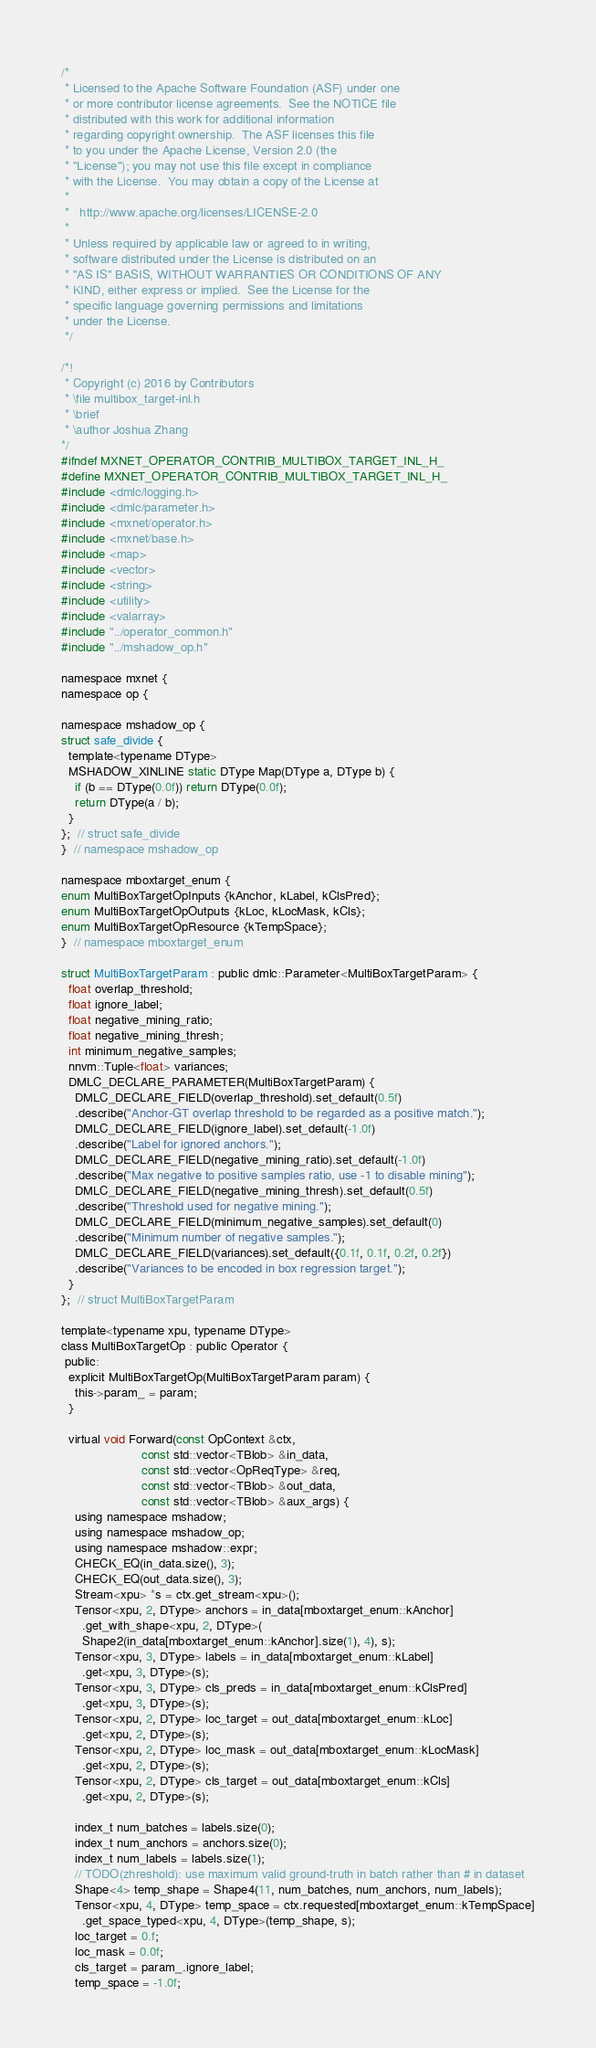<code> <loc_0><loc_0><loc_500><loc_500><_C_>/*
 * Licensed to the Apache Software Foundation (ASF) under one
 * or more contributor license agreements.  See the NOTICE file
 * distributed with this work for additional information
 * regarding copyright ownership.  The ASF licenses this file
 * to you under the Apache License, Version 2.0 (the
 * "License"); you may not use this file except in compliance
 * with the License.  You may obtain a copy of the License at
 *
 *   http://www.apache.org/licenses/LICENSE-2.0
 *
 * Unless required by applicable law or agreed to in writing,
 * software distributed under the License is distributed on an
 * "AS IS" BASIS, WITHOUT WARRANTIES OR CONDITIONS OF ANY
 * KIND, either express or implied.  See the License for the
 * specific language governing permissions and limitations
 * under the License.
 */

/*!
 * Copyright (c) 2016 by Contributors
 * \file multibox_target-inl.h
 * \brief
 * \author Joshua Zhang
*/
#ifndef MXNET_OPERATOR_CONTRIB_MULTIBOX_TARGET_INL_H_
#define MXNET_OPERATOR_CONTRIB_MULTIBOX_TARGET_INL_H_
#include <dmlc/logging.h>
#include <dmlc/parameter.h>
#include <mxnet/operator.h>
#include <mxnet/base.h>
#include <map>
#include <vector>
#include <string>
#include <utility>
#include <valarray>
#include "../operator_common.h"
#include "../mshadow_op.h"

namespace mxnet {
namespace op {

namespace mshadow_op {
struct safe_divide {
  template<typename DType>
  MSHADOW_XINLINE static DType Map(DType a, DType b) {
    if (b == DType(0.0f)) return DType(0.0f);
    return DType(a / b);
  }
};  // struct safe_divide
}  // namespace mshadow_op

namespace mboxtarget_enum {
enum MultiBoxTargetOpInputs {kAnchor, kLabel, kClsPred};
enum MultiBoxTargetOpOutputs {kLoc, kLocMask, kCls};
enum MultiBoxTargetOpResource {kTempSpace};
}  // namespace mboxtarget_enum

struct MultiBoxTargetParam : public dmlc::Parameter<MultiBoxTargetParam> {
  float overlap_threshold;
  float ignore_label;
  float negative_mining_ratio;
  float negative_mining_thresh;
  int minimum_negative_samples;
  nnvm::Tuple<float> variances;
  DMLC_DECLARE_PARAMETER(MultiBoxTargetParam) {
    DMLC_DECLARE_FIELD(overlap_threshold).set_default(0.5f)
    .describe("Anchor-GT overlap threshold to be regarded as a positive match.");
    DMLC_DECLARE_FIELD(ignore_label).set_default(-1.0f)
    .describe("Label for ignored anchors.");
    DMLC_DECLARE_FIELD(negative_mining_ratio).set_default(-1.0f)
    .describe("Max negative to positive samples ratio, use -1 to disable mining");
    DMLC_DECLARE_FIELD(negative_mining_thresh).set_default(0.5f)
    .describe("Threshold used for negative mining.");
    DMLC_DECLARE_FIELD(minimum_negative_samples).set_default(0)
    .describe("Minimum number of negative samples.");
    DMLC_DECLARE_FIELD(variances).set_default({0.1f, 0.1f, 0.2f, 0.2f})
    .describe("Variances to be encoded in box regression target.");
  }
};  // struct MultiBoxTargetParam

template<typename xpu, typename DType>
class MultiBoxTargetOp : public Operator {
 public:
  explicit MultiBoxTargetOp(MultiBoxTargetParam param) {
    this->param_ = param;
  }

  virtual void Forward(const OpContext &ctx,
                       const std::vector<TBlob> &in_data,
                       const std::vector<OpReqType> &req,
                       const std::vector<TBlob> &out_data,
                       const std::vector<TBlob> &aux_args) {
    using namespace mshadow;
    using namespace mshadow_op;
    using namespace mshadow::expr;
    CHECK_EQ(in_data.size(), 3);
    CHECK_EQ(out_data.size(), 3);
    Stream<xpu> *s = ctx.get_stream<xpu>();
    Tensor<xpu, 2, DType> anchors = in_data[mboxtarget_enum::kAnchor]
      .get_with_shape<xpu, 2, DType>(
      Shape2(in_data[mboxtarget_enum::kAnchor].size(1), 4), s);
    Tensor<xpu, 3, DType> labels = in_data[mboxtarget_enum::kLabel]
      .get<xpu, 3, DType>(s);
    Tensor<xpu, 3, DType> cls_preds = in_data[mboxtarget_enum::kClsPred]
      .get<xpu, 3, DType>(s);
    Tensor<xpu, 2, DType> loc_target = out_data[mboxtarget_enum::kLoc]
      .get<xpu, 2, DType>(s);
    Tensor<xpu, 2, DType> loc_mask = out_data[mboxtarget_enum::kLocMask]
      .get<xpu, 2, DType>(s);
    Tensor<xpu, 2, DType> cls_target = out_data[mboxtarget_enum::kCls]
      .get<xpu, 2, DType>(s);

    index_t num_batches = labels.size(0);
    index_t num_anchors = anchors.size(0);
    index_t num_labels = labels.size(1);
    // TODO(zhreshold): use maximum valid ground-truth in batch rather than # in dataset
    Shape<4> temp_shape = Shape4(11, num_batches, num_anchors, num_labels);
    Tensor<xpu, 4, DType> temp_space = ctx.requested[mboxtarget_enum::kTempSpace]
      .get_space_typed<xpu, 4, DType>(temp_shape, s);
    loc_target = 0.f;
    loc_mask = 0.0f;
    cls_target = param_.ignore_label;
    temp_space = -1.0f;</code> 